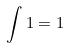Convert formula to latex. <formula><loc_0><loc_0><loc_500><loc_500>\int 1 = 1</formula> 